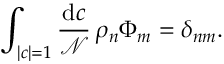<formula> <loc_0><loc_0><loc_500><loc_500>\int _ { | c | = 1 } { \frac { d c } { \mathcal { N } } } \, \rho _ { n } \Phi _ { m } = \delta _ { n m } .</formula> 